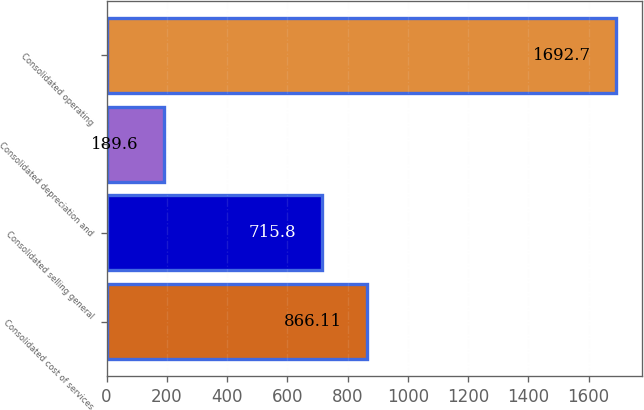Convert chart to OTSL. <chart><loc_0><loc_0><loc_500><loc_500><bar_chart><fcel>Consolidated cost of services<fcel>Consolidated selling general<fcel>Consolidated depreciation and<fcel>Consolidated operating<nl><fcel>866.11<fcel>715.8<fcel>189.6<fcel>1692.7<nl></chart> 